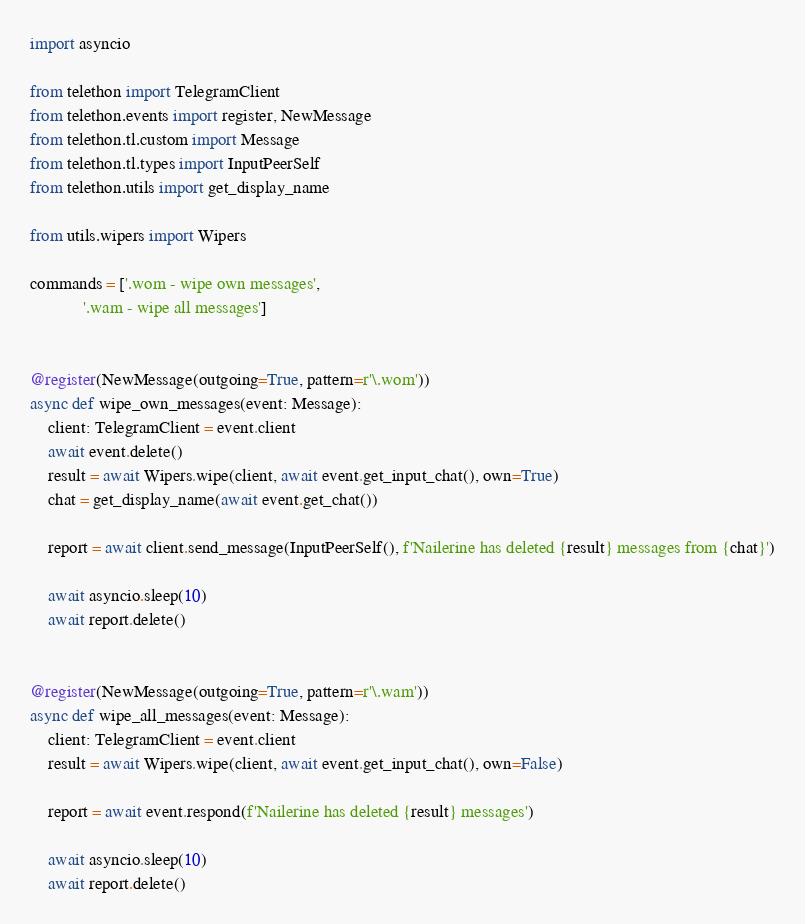Convert code to text. <code><loc_0><loc_0><loc_500><loc_500><_Python_>import asyncio

from telethon import TelegramClient
from telethon.events import register, NewMessage
from telethon.tl.custom import Message
from telethon.tl.types import InputPeerSelf
from telethon.utils import get_display_name

from utils.wipers import Wipers

commands = ['.wom - wipe own messages',
            '.wam - wipe all messages']


@register(NewMessage(outgoing=True, pattern=r'\.wom'))
async def wipe_own_messages(event: Message):
    client: TelegramClient = event.client
    await event.delete()
    result = await Wipers.wipe(client, await event.get_input_chat(), own=True)
    chat = get_display_name(await event.get_chat())

    report = await client.send_message(InputPeerSelf(), f'Nailerine has deleted {result} messages from {chat}')

    await asyncio.sleep(10)
    await report.delete()


@register(NewMessage(outgoing=True, pattern=r'\.wam'))
async def wipe_all_messages(event: Message):
    client: TelegramClient = event.client
    result = await Wipers.wipe(client, await event.get_input_chat(), own=False)

    report = await event.respond(f'Nailerine has deleted {result} messages')

    await asyncio.sleep(10)
    await report.delete()
</code> 